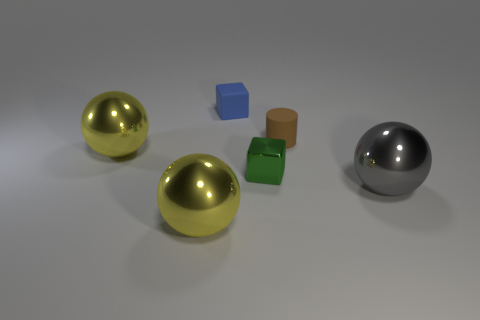How does the lighting in this image affect the appearance of the objects? The lighting in the image is diffused, casting soft shadows and highlighting the reflective properties of the metallic-looking balls. This soft light enhances the three-dimensionality of the objects and accentuates their textures. 